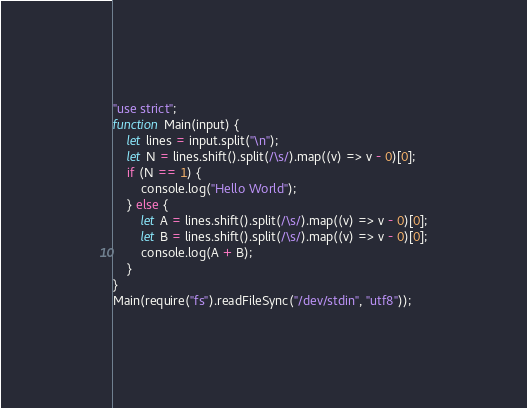Convert code to text. <code><loc_0><loc_0><loc_500><loc_500><_JavaScript_>"use strict";
function Main(input) {
    let lines = input.split("\n");
    let N = lines.shift().split(/\s/).map((v) => v - 0)[0];
    if (N == 1) {
        console.log("Hello World");
    } else {
        let A = lines.shift().split(/\s/).map((v) => v - 0)[0];
        let B = lines.shift().split(/\s/).map((v) => v - 0)[0];
        console.log(A + B);
    }
}
Main(require("fs").readFileSync("/dev/stdin", "utf8"));
</code> 